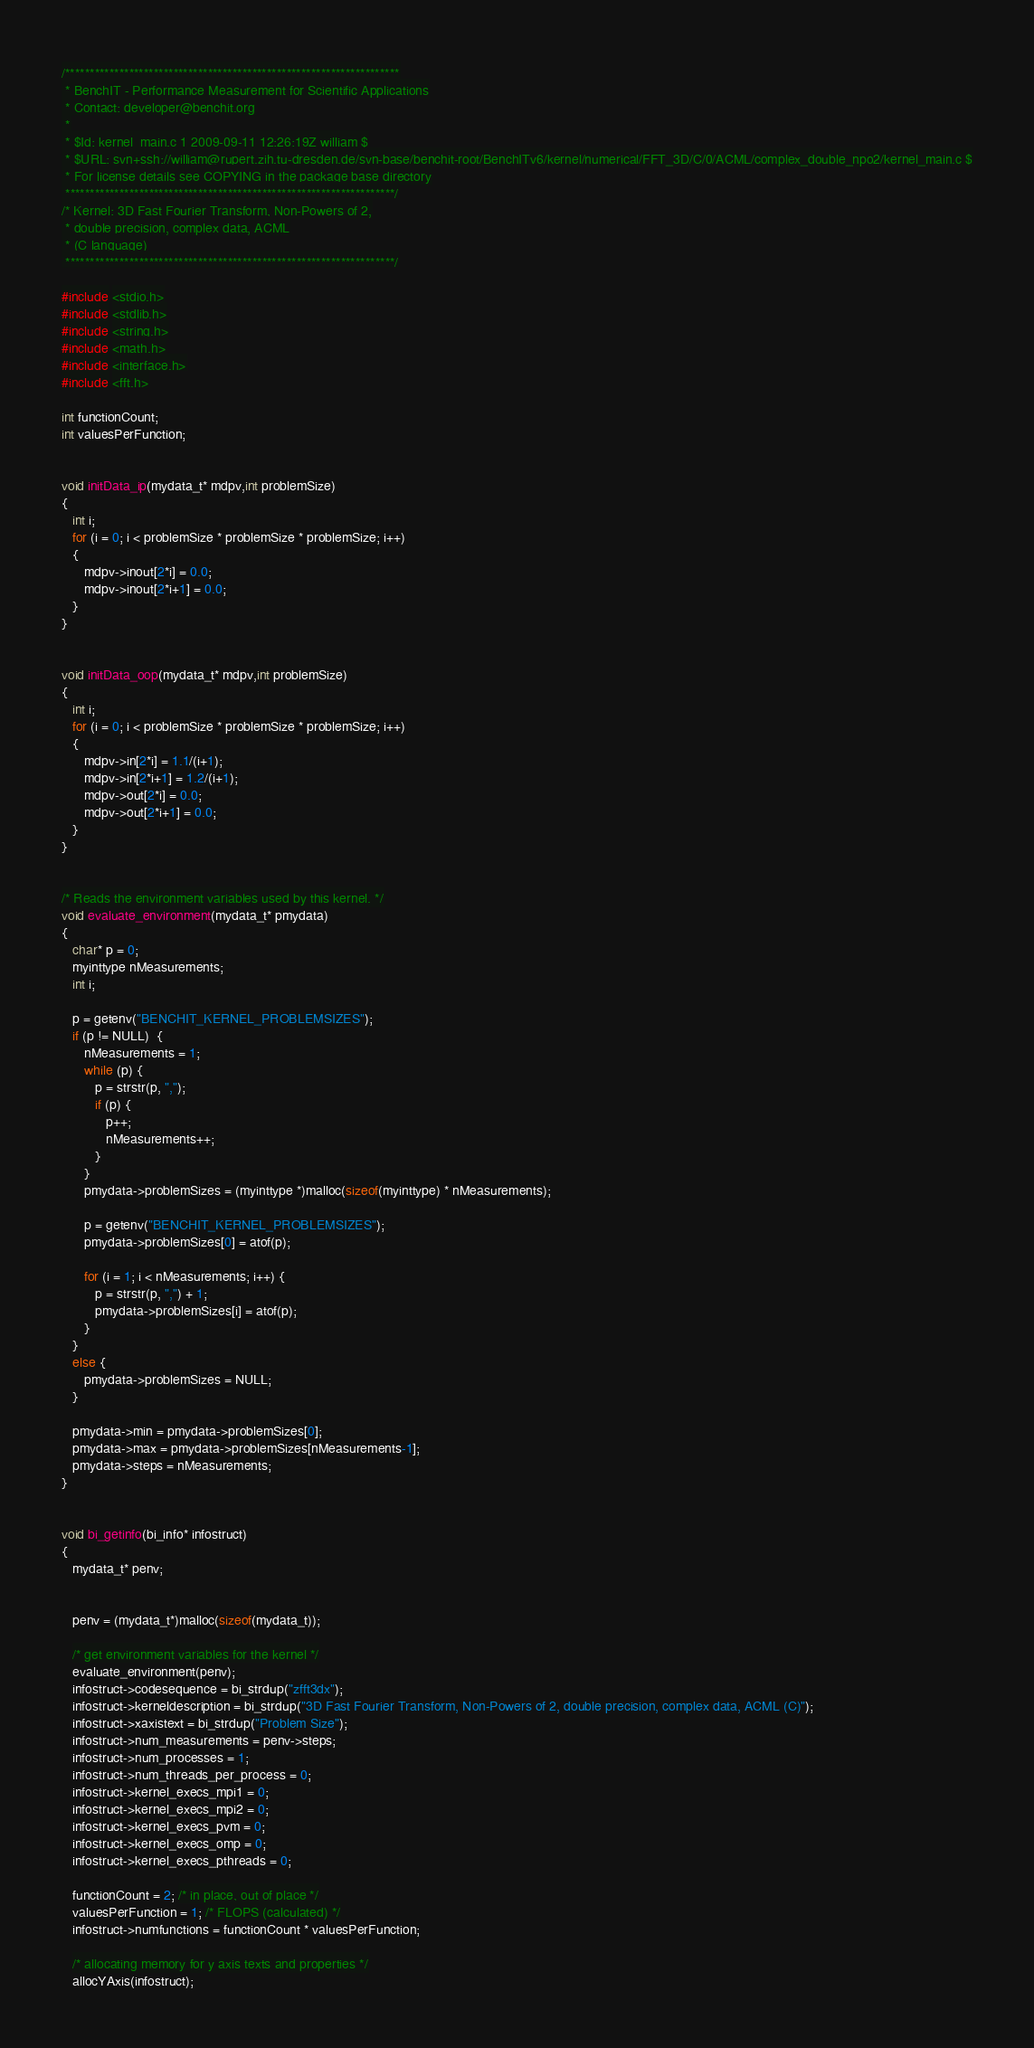Convert code to text. <code><loc_0><loc_0><loc_500><loc_500><_C_>/********************************************************************
 * BenchIT - Performance Measurement for Scientific Applications
 * Contact: developer@benchit.org
 *
 * $Id: kernel_main.c 1 2009-09-11 12:26:19Z william $
 * $URL: svn+ssh://william@rupert.zih.tu-dresden.de/svn-base/benchit-root/BenchITv6/kernel/numerical/FFT_3D/C/0/ACML/complex_double_npo2/kernel_main.c $
 * For license details see COPYING in the package base directory
 *******************************************************************/
/* Kernel: 3D Fast Fourier Transform, Non-Powers of 2,
 * double precision, complex data, ACML
 * (C language)
 *******************************************************************/

#include <stdio.h>
#include <stdlib.h>
#include <string.h>
#include <math.h>
#include <interface.h>
#include <fft.h>

int functionCount;
int valuesPerFunction;


void initData_ip(mydata_t* mdpv,int problemSize)
{
   int i;
   for (i = 0; i < problemSize * problemSize * problemSize; i++)
   {
      mdpv->inout[2*i] = 0.0;
      mdpv->inout[2*i+1] = 0.0;
   }
}


void initData_oop(mydata_t* mdpv,int problemSize)
{
   int i;
   for (i = 0; i < problemSize * problemSize * problemSize; i++)
   {
      mdpv->in[2*i] = 1.1/(i+1);
      mdpv->in[2*i+1] = 1.2/(i+1);
      mdpv->out[2*i] = 0.0;
      mdpv->out[2*i+1] = 0.0;
   }
}


/* Reads the environment variables used by this kernel. */
void evaluate_environment(mydata_t* pmydata)
{
   char* p = 0;
   myinttype nMeasurements;
   int i;

   p = getenv("BENCHIT_KERNEL_PROBLEMSIZES");
   if (p != NULL)  {
      nMeasurements = 1;
      while (p) {
         p = strstr(p, ",");
         if (p) {
            p++;
            nMeasurements++;
         }
      }
      pmydata->problemSizes = (myinttype *)malloc(sizeof(myinttype) * nMeasurements);

      p = getenv("BENCHIT_KERNEL_PROBLEMSIZES");
      pmydata->problemSizes[0] = atof(p);

      for (i = 1; i < nMeasurements; i++) {
         p = strstr(p, ",") + 1;
         pmydata->problemSizes[i] = atof(p);
      }
   }
   else {
      pmydata->problemSizes = NULL;
   }

   pmydata->min = pmydata->problemSizes[0];
   pmydata->max = pmydata->problemSizes[nMeasurements-1];
   pmydata->steps = nMeasurements;
}


void bi_getinfo(bi_info* infostruct)
{
   mydata_t* penv;


   penv = (mydata_t*)malloc(sizeof(mydata_t));

   /* get environment variables for the kernel */
   evaluate_environment(penv);
   infostruct->codesequence = bi_strdup("zfft3dx");
   infostruct->kerneldescription = bi_strdup("3D Fast Fourier Transform, Non-Powers of 2, double precision, complex data, ACML (C)");
   infostruct->xaxistext = bi_strdup("Problem Size");
   infostruct->num_measurements = penv->steps;
   infostruct->num_processes = 1;
   infostruct->num_threads_per_process = 0;
   infostruct->kernel_execs_mpi1 = 0;
   infostruct->kernel_execs_mpi2 = 0;
   infostruct->kernel_execs_pvm = 0;
   infostruct->kernel_execs_omp = 0;
   infostruct->kernel_execs_pthreads = 0;

   functionCount = 2; /* in place, out of place */
   valuesPerFunction = 1; /* FLOPS (calculated) */
   infostruct->numfunctions = functionCount * valuesPerFunction;

   /* allocating memory for y axis texts and properties */
   allocYAxis(infostruct);</code> 